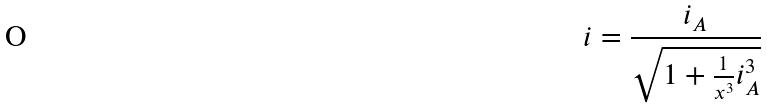<formula> <loc_0><loc_0><loc_500><loc_500>i = \frac { i _ { A } } { \sqrt { 1 + \frac { 1 } { x ^ { 3 } } i _ { A } ^ { 3 } } }</formula> 